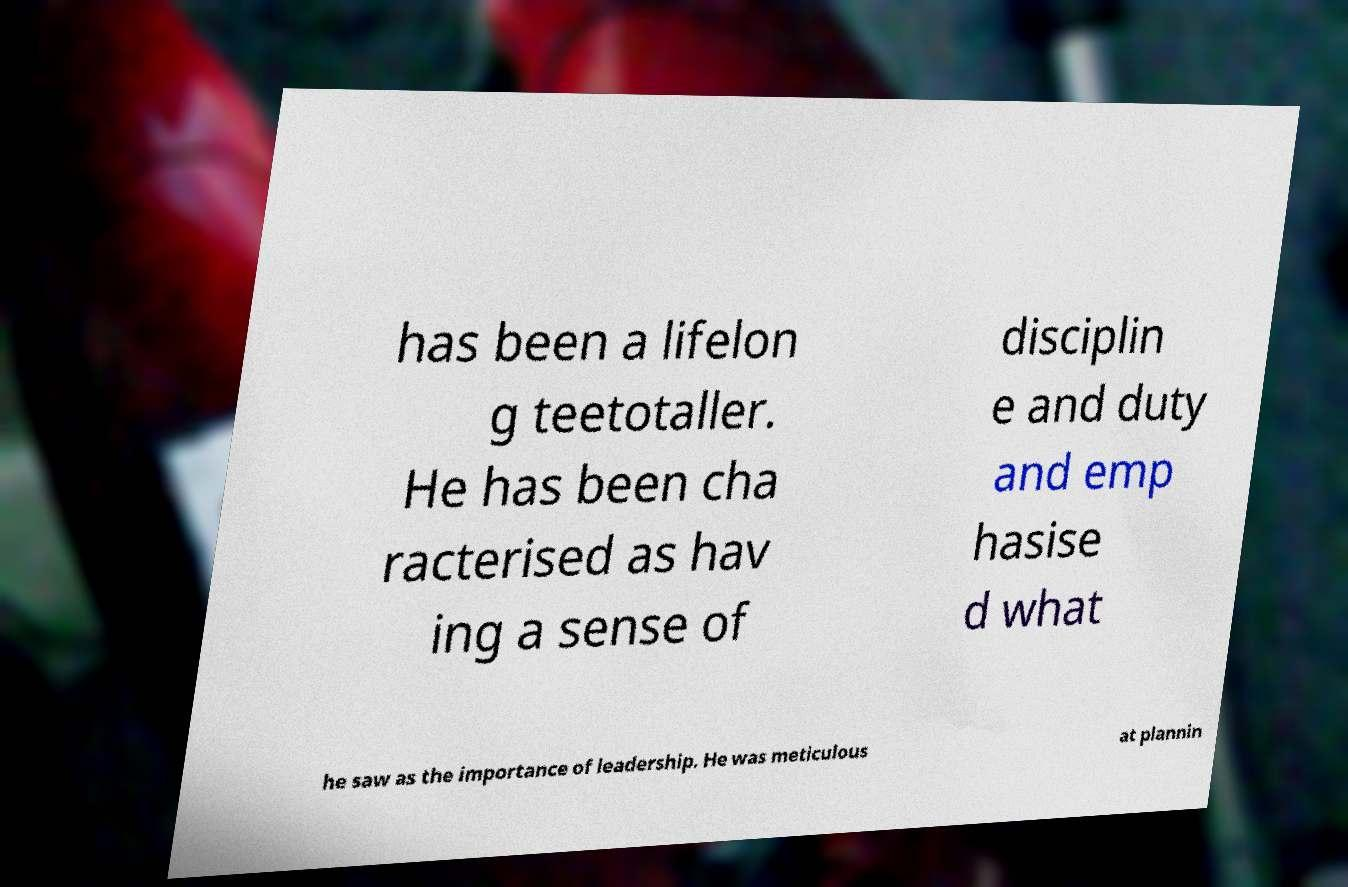Can you read and provide the text displayed in the image?This photo seems to have some interesting text. Can you extract and type it out for me? has been a lifelon g teetotaller. He has been cha racterised as hav ing a sense of disciplin e and duty and emp hasise d what he saw as the importance of leadership. He was meticulous at plannin 